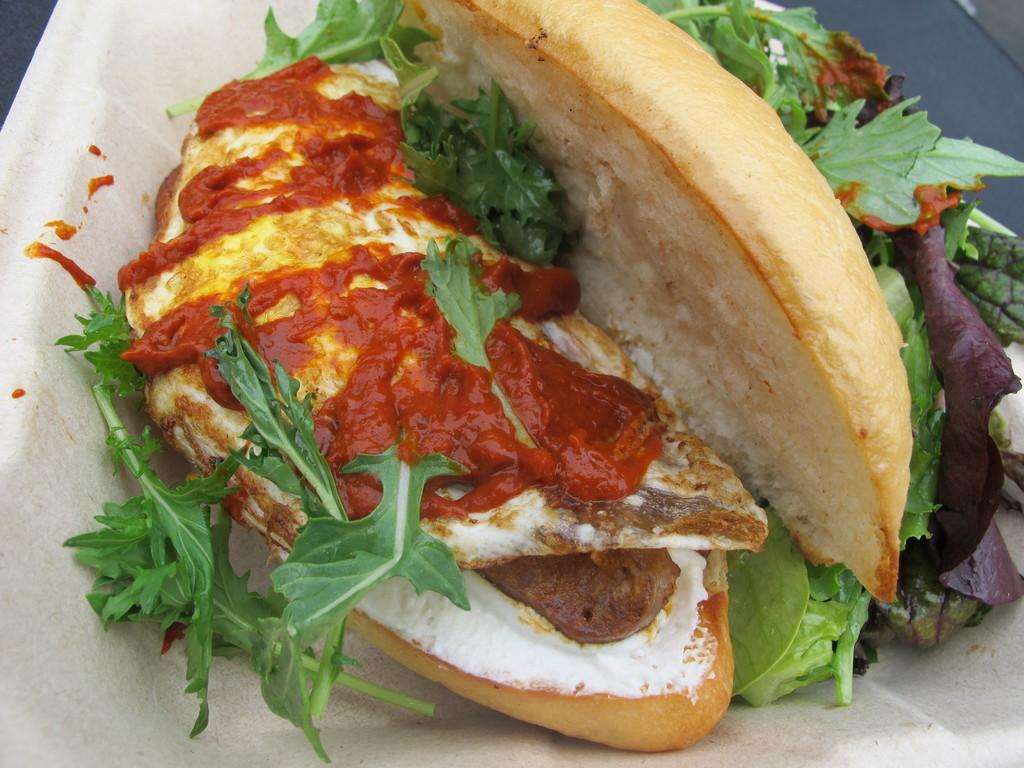What is the main subject of the image? There is a food item in the image. Can you describe the surface on which the food item is placed? The food item is on a white surface. How does the food item contribute to the quiet atmosphere in the image? The image does not convey any information about the atmosphere or noise level, and the food item's presence does not inherently affect the quietness of the scene. 